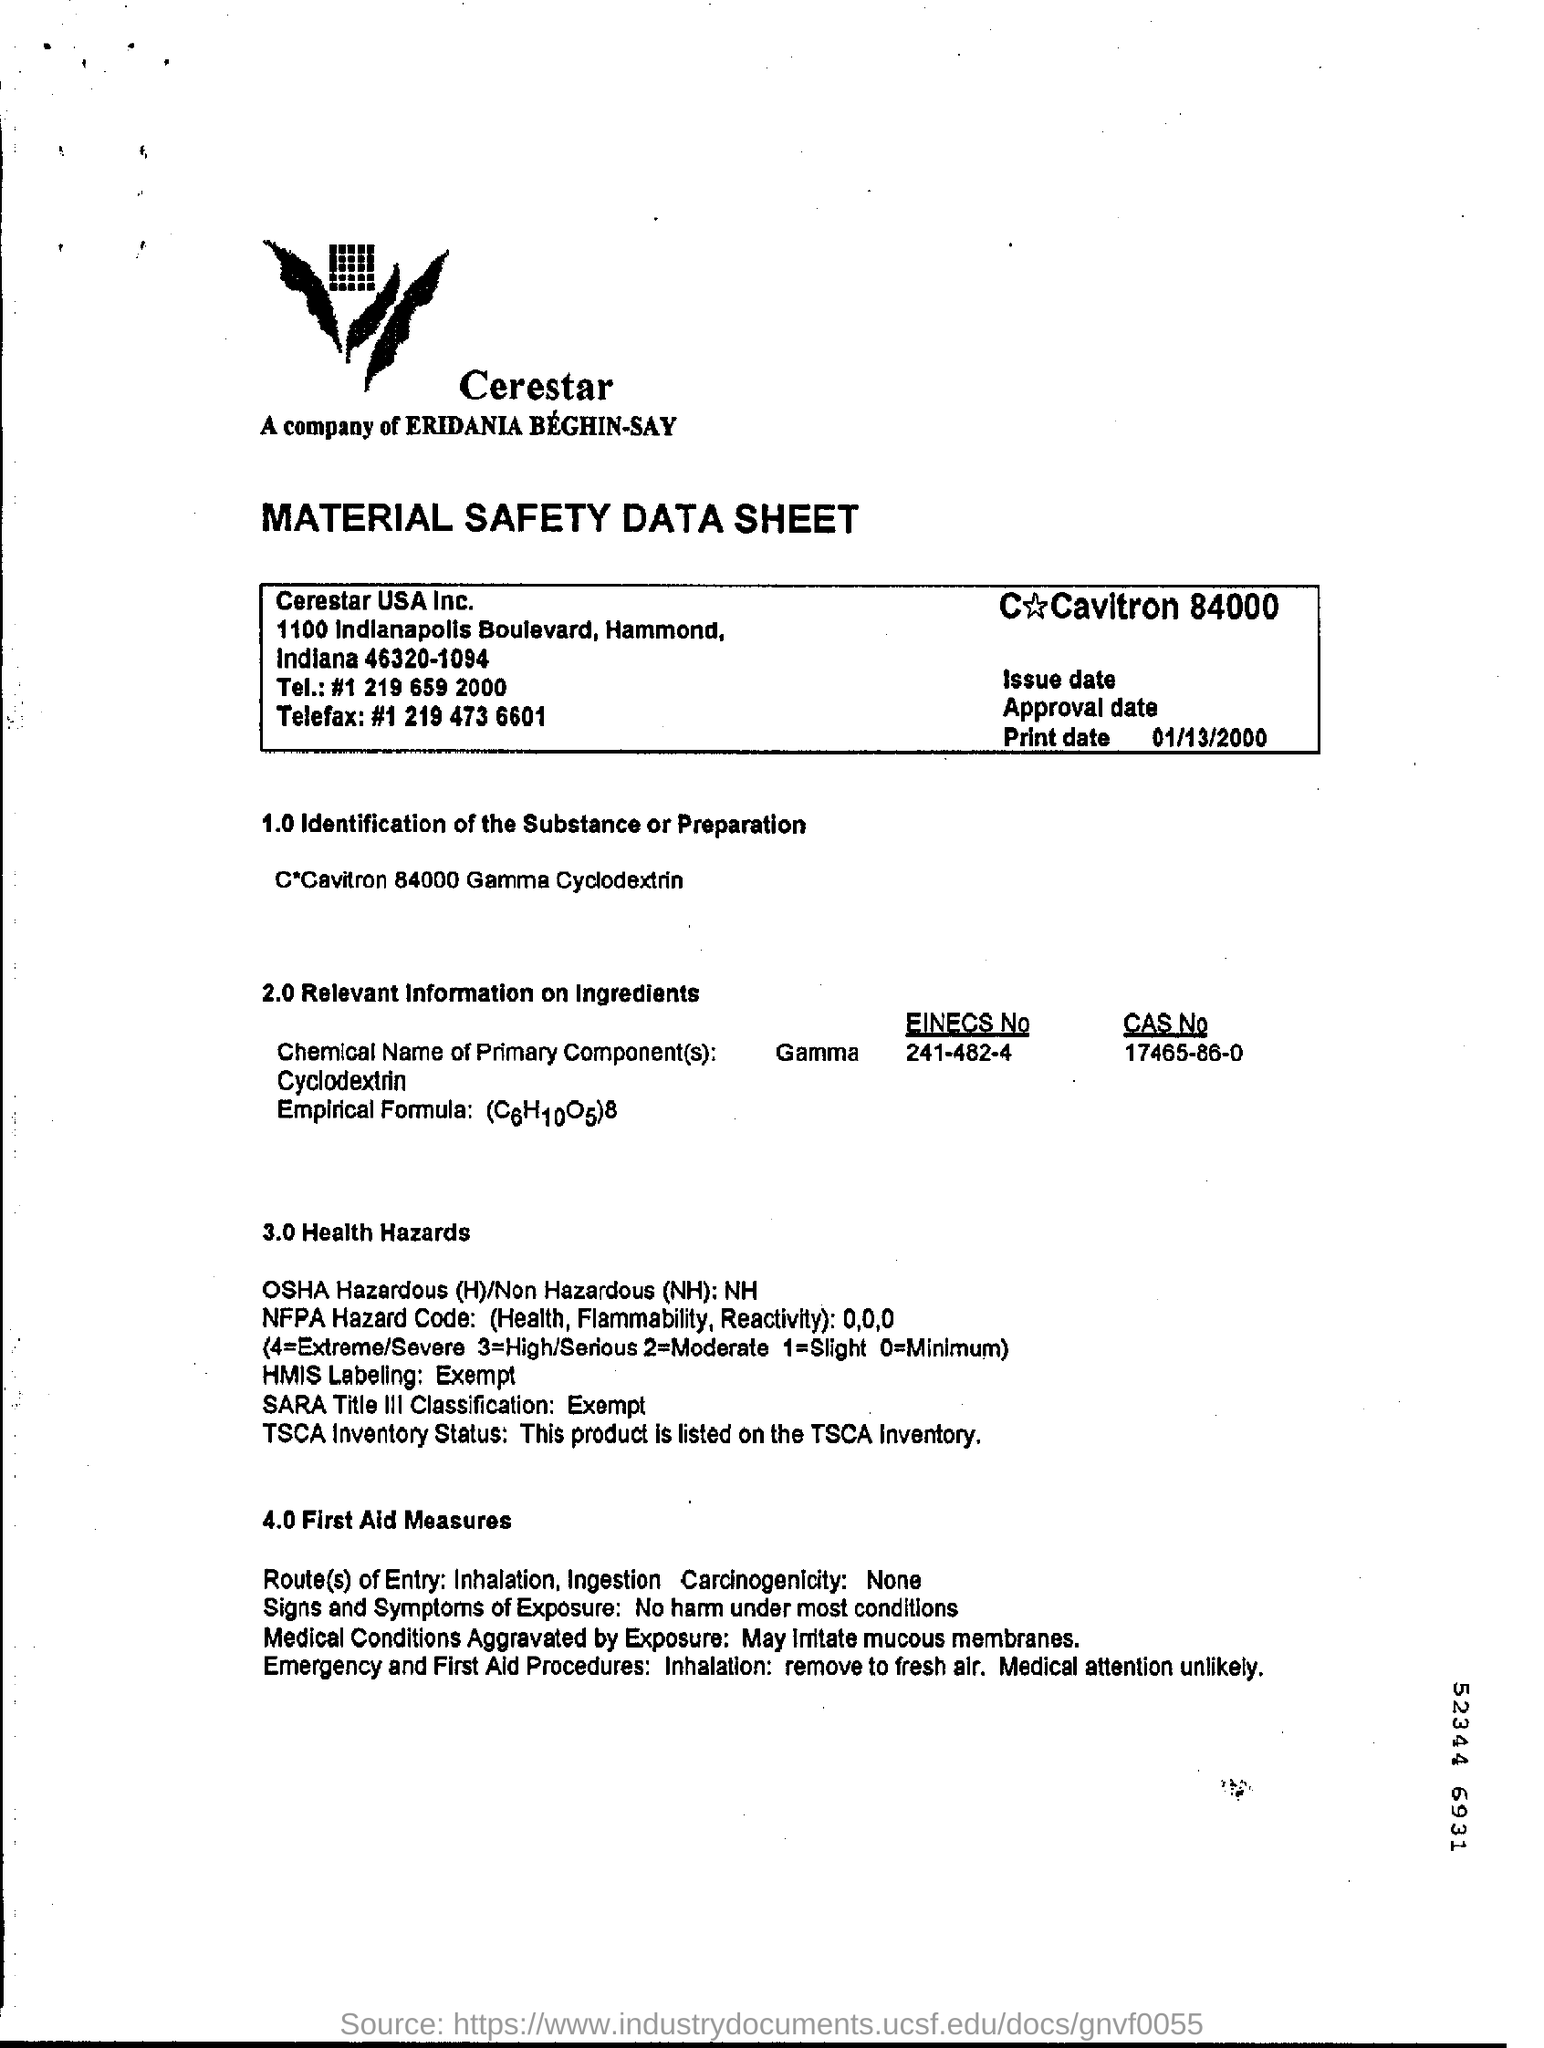What type of data sheet is this?
Your response must be concise. Material Safety. What are route(s) of Entry?
Your answer should be compact. Inhalation, Ingestion. 